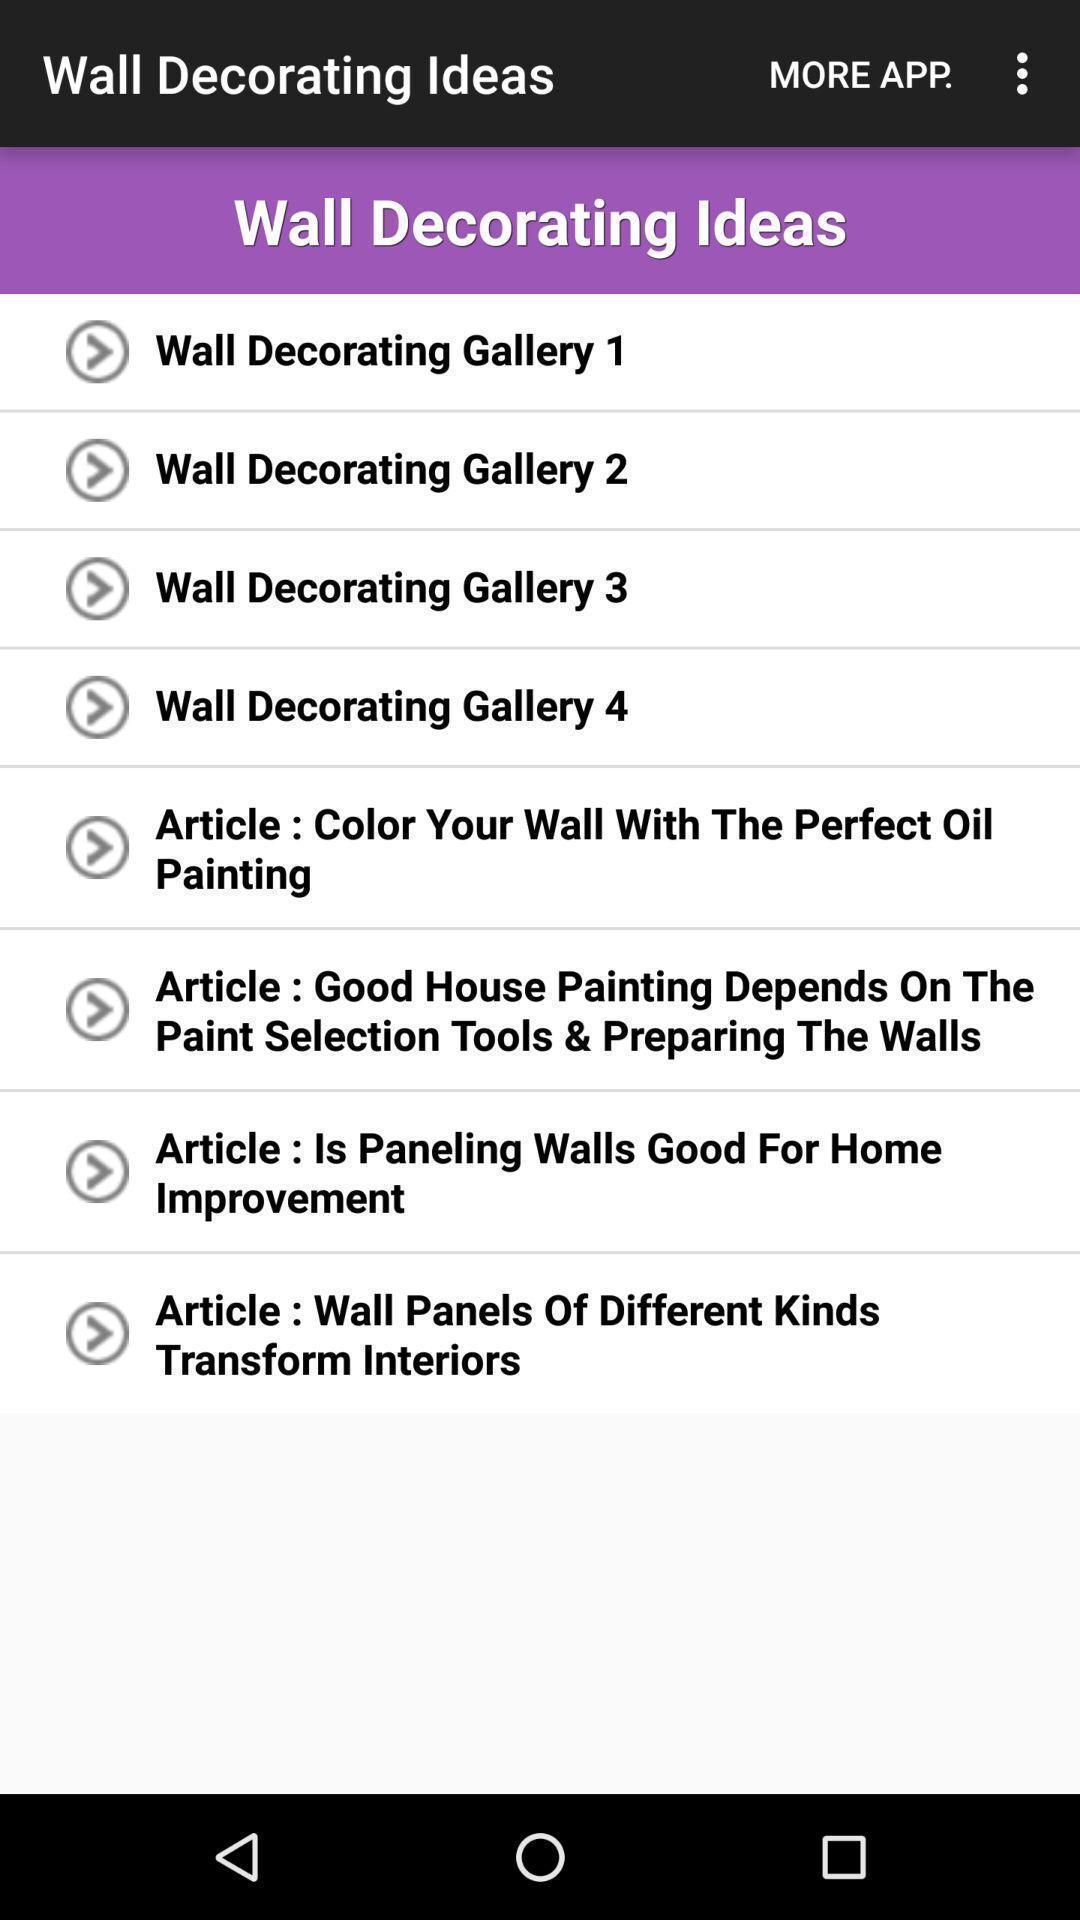Give me a summary of this screen capture. Screen displaying a list of decoration articles. 